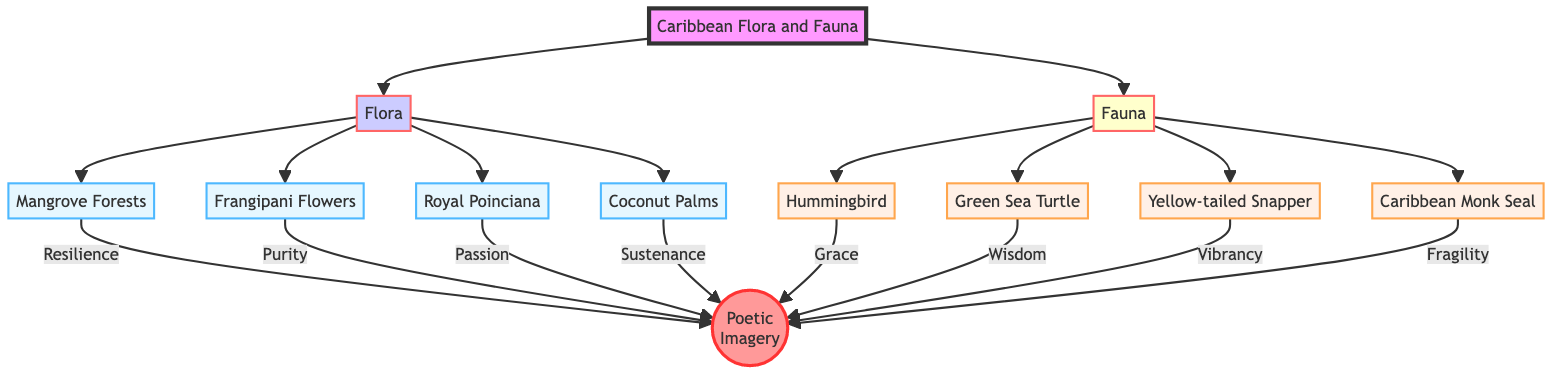What types of elements does the flowchart include? The flowchart categorizes the elements into two types: Flora and Fauna. These nodes represent the different categories of plants and animals found in the Caribbean.
Answer: Flora and Fauna How many Flora elements are represented in the diagram? Counting the nodes listed under the Flora category, there are four specific elements: Mangrove Forests, Frangipani Flowers, Royal Poinciana, and Coconut Palms.
Answer: Four What do Mangrove Forests symbolize in the poetic imagery? The diagram indicates that Mangrove Forests symbolize resilience, which is a key thematic element associated with their description in the flowchart.
Answer: Resilience Which Fauna element is associated with wisdom? The Green Sea Turtle is explicitly linked to the concept of wisdom in the diagram flow, highlighting its deeper narrative significance.
Answer: Green Sea Turtle What is the relationship between Royal Poinciana and poetic imagery? The Royal Poinciana represents passion in the poetic imagery, as noted in the flowchart. This connects the physical traits of the tree to a thematic essence.
Answer: Passion How many Fauna elements have descriptions related to vibrancy? The flowchart indicates that there is one Fauna element, the Yellow-tailed Snapper, which is described as embodying vibrancy, thus answering the question on vibrancy representation.
Answer: One What element is classified as extinct? The Caribbean Monk Seal is identified as the extinct element within the Fauna category, highlighting its environmental significance.
Answer: Caribbean Monk Seal Which Flora element is associated with purity? According to the flowchart, Frangipani Flowers are associated with purity, drawing a clear connection to their symbolism in the poetic imagery context.
Answer: Frangipani Flowers What color is used to represent the Flora category in the flowchart? The Flora category is visually represented with a light blue color (#e6f7ff), as specified in the code provided for the diagram's styling.
Answer: Light blue 